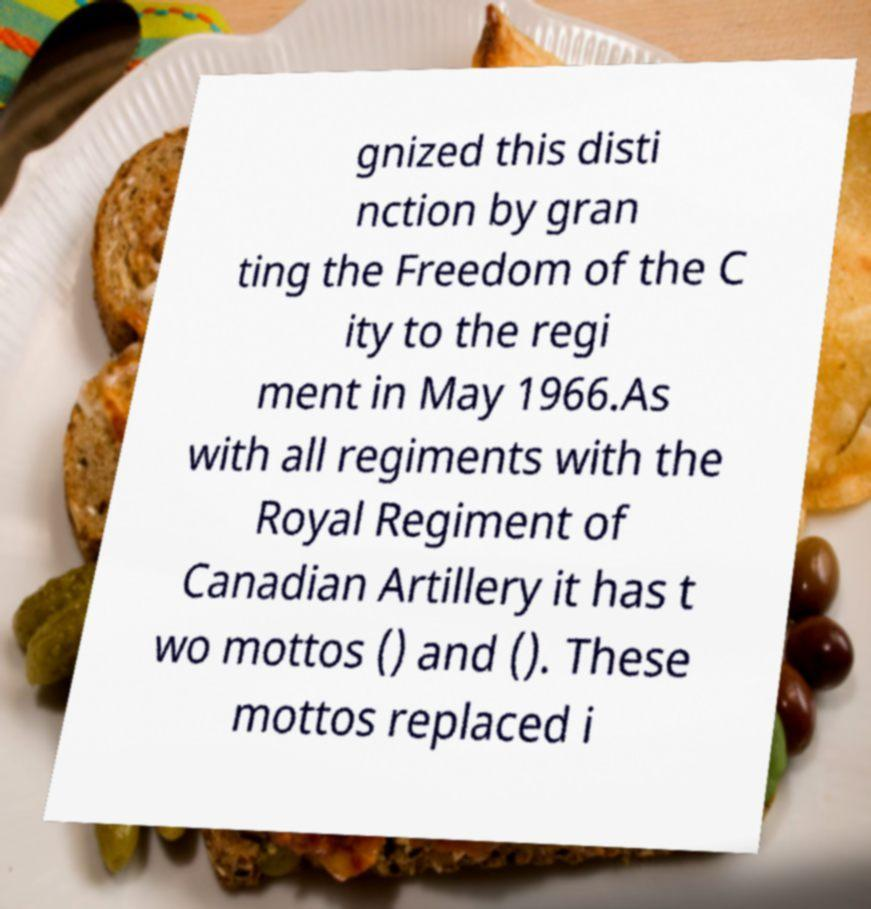Could you extract and type out the text from this image? gnized this disti nction by gran ting the Freedom of the C ity to the regi ment in May 1966.As with all regiments with the Royal Regiment of Canadian Artillery it has t wo mottos () and (). These mottos replaced i 